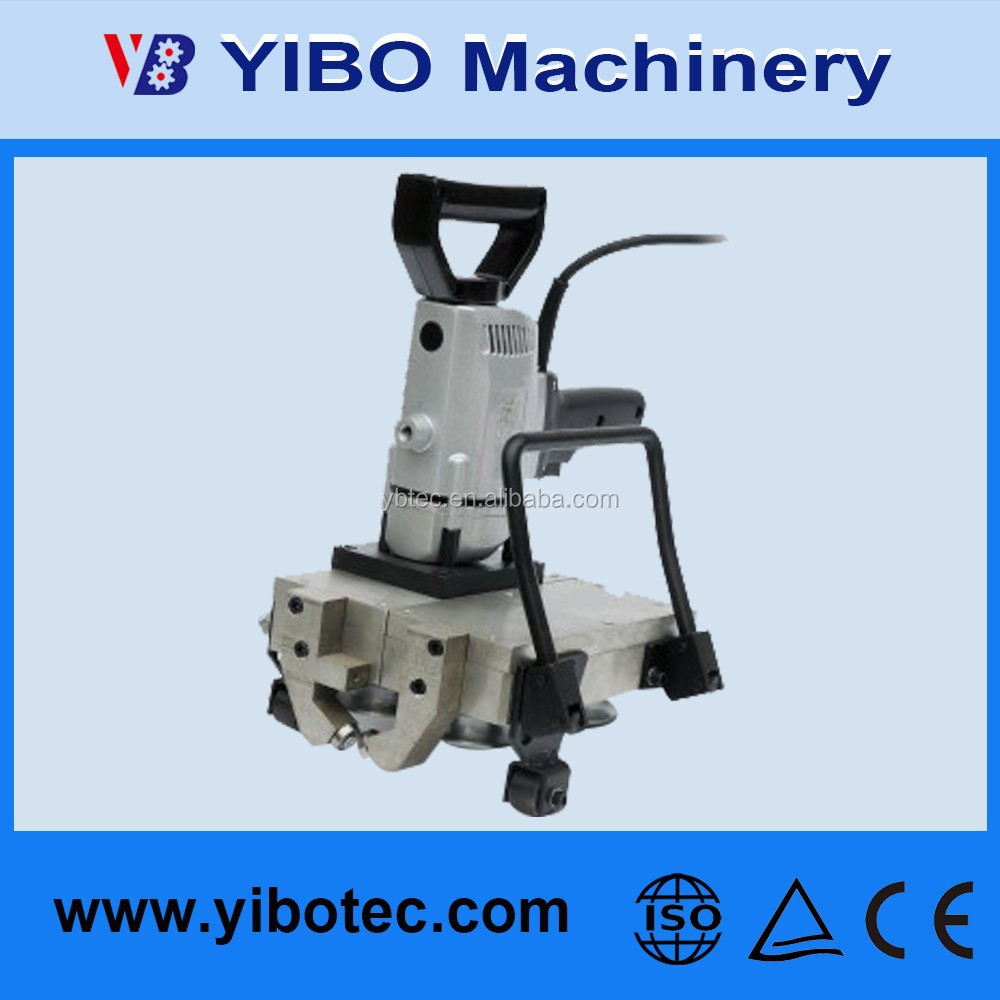Describe a short realistic scenario where this machine is being used in a manufacturing plant. In a bustling manufacturing plant producing automotive parts, this machine is stationed at a workbench where it rapidly cuts and shapes metal components. An operator, equipped with safety gear, programs the machine via its user-friendly control panel, setting it to produce a batch of precisely measured metal brackets. The machine performs each cut with precision, ensuring consistency and quality across all pieces. Its robust build and compliance with safety standards reassure the operator of its reliability and safety during the intensive work shift. 